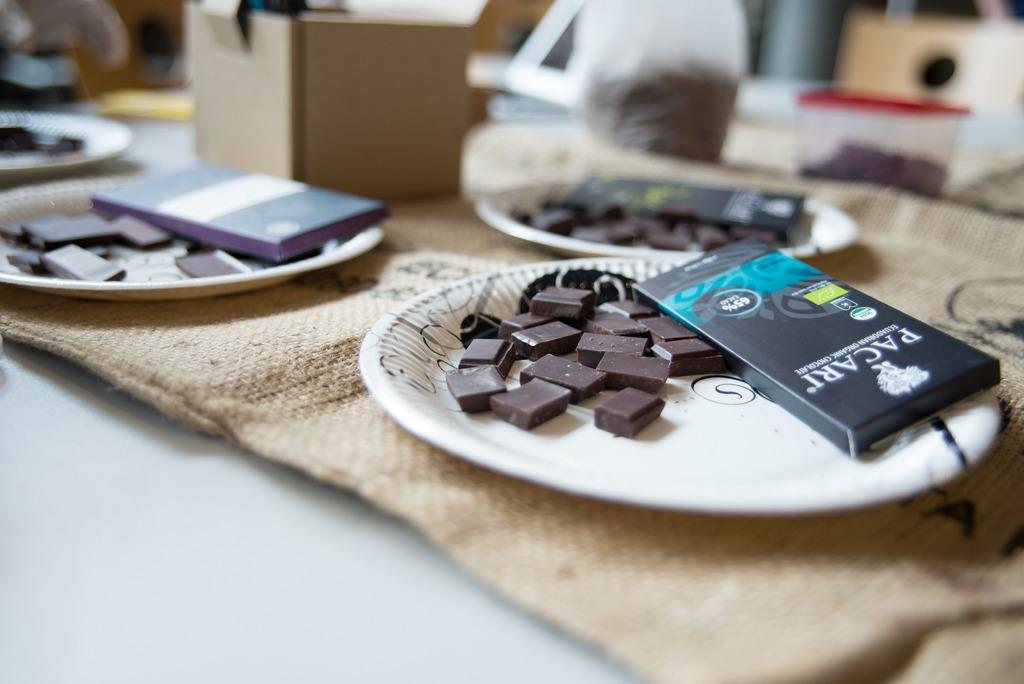<image>
Summarize the visual content of the image. A plate of Pacari chocolate pieces are on the table for you. 